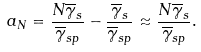Convert formula to latex. <formula><loc_0><loc_0><loc_500><loc_500>a _ { N } = \frac { N \overline { \gamma } _ { s } } { \overline { \gamma } _ { s p } } - \frac { \overline { \gamma } _ { s } } { \overline { \gamma } _ { s p } } \approx \frac { N \overline { \gamma } _ { s } } { \overline { \gamma } _ { s p } } .</formula> 